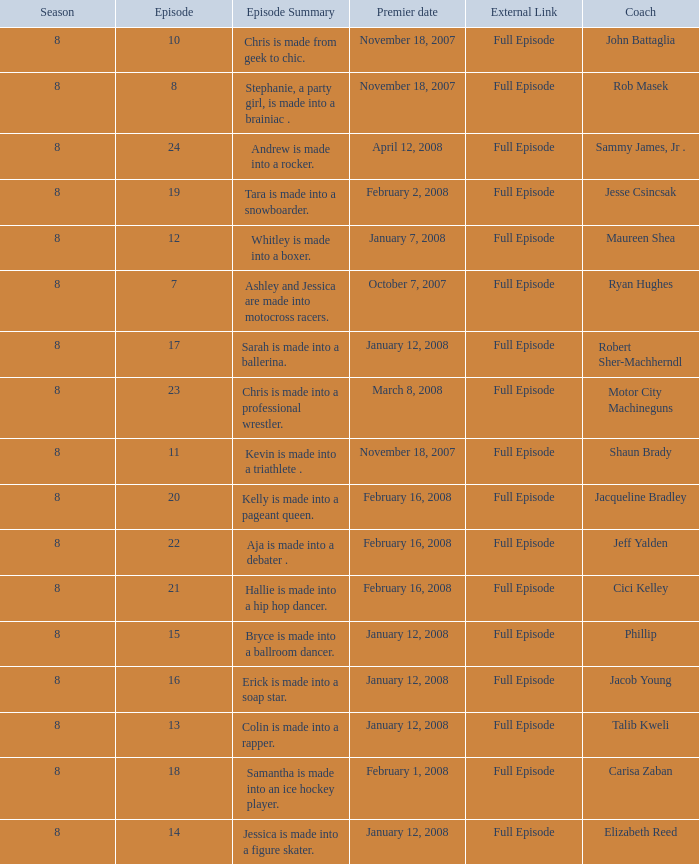Which Maximum episode premiered March 8, 2008? 23.0. 